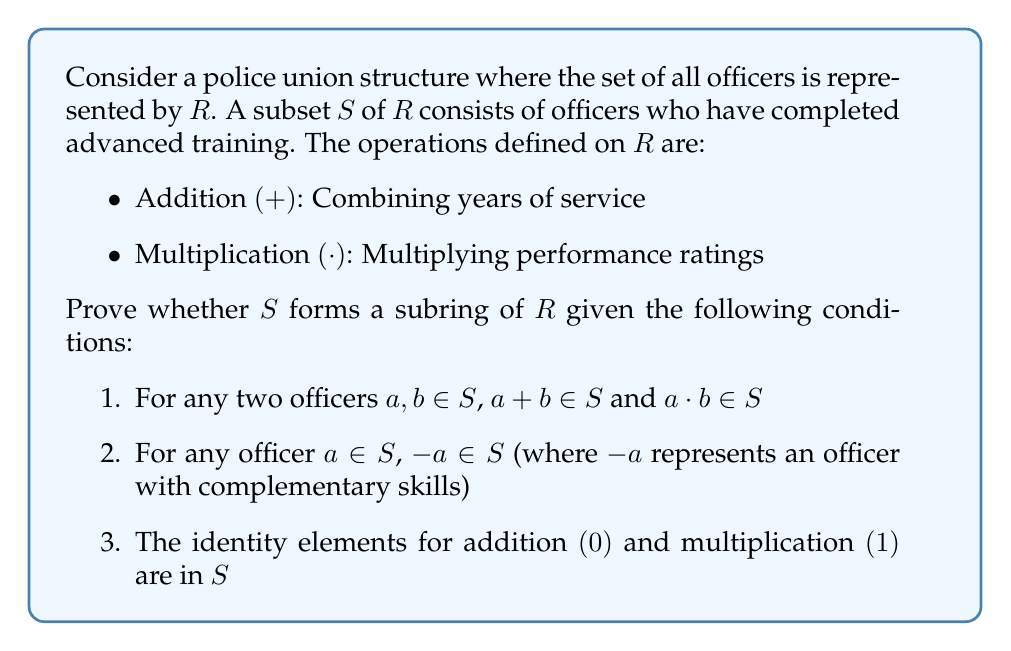Could you help me with this problem? To prove that $S$ is a subring of $R$, we need to show that it satisfies the following properties:

1. $(S, +)$ is a subgroup of $(R, +)$
2. $(S, \cdot)$ is a semigroup
3. The distributive laws hold in $S$

Let's examine each property:

1. $(S, +)$ is a subgroup of $(R, +)$:
   a) Closure: Given in condition 1
   b) Associativity: Inherited from $R$
   c) Identity: Given in condition 3
   d) Inverse: Given in condition 2

2. $(S, \cdot)$ is a semigroup:
   a) Closure: Given in condition 1
   b) Associativity: Inherited from $R$

3. Distributive laws:
   These are inherited from $R$ since $S \subseteq R$

Therefore, $S$ satisfies all the properties of a subring.

Additionally, we can note that:
- The identity for addition $(0)$ represents an officer with no years of service
- The identity for multiplication $(1)$ represents an officer with a neutral performance rating
- The existence of these elements in $S$ (condition 3) ensures that $S$ is a subring with unity
Answer: Yes, $S$ forms a subring of $R$. It satisfies all the necessary conditions: $(S, +)$ is a subgroup of $(R, +)$, $(S, \cdot)$ is a semigroup, and the distributive laws hold. Moreover, $S$ is a subring with unity as it contains the identity elements for both addition and multiplication. 